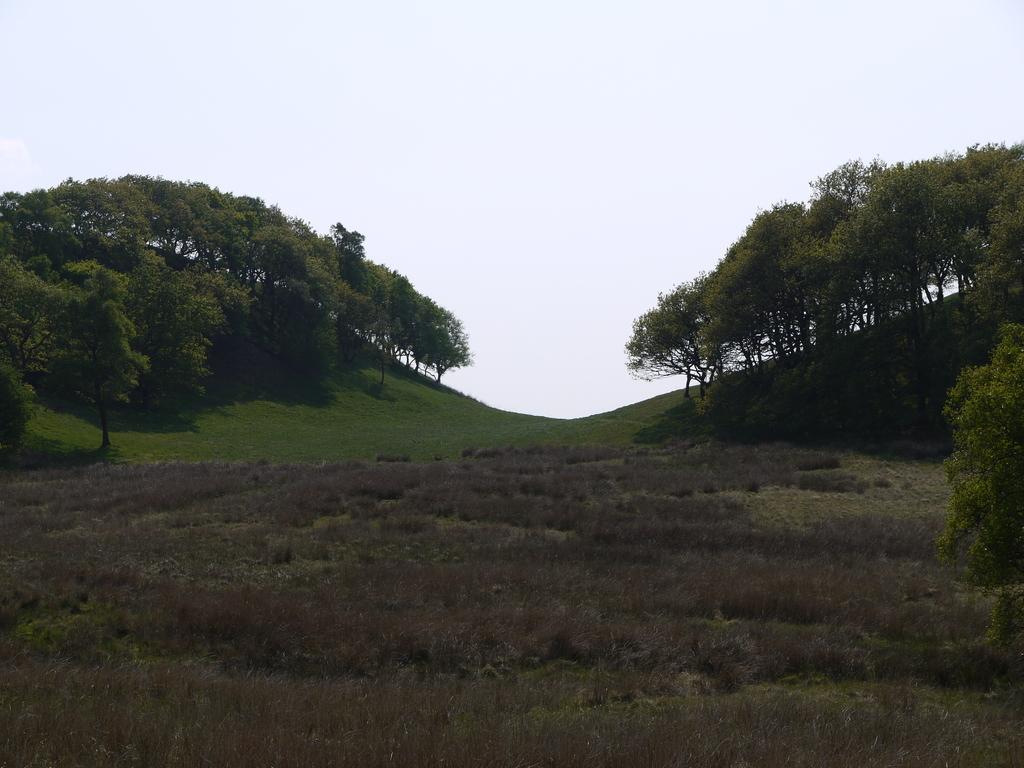Can you describe this image briefly? In this picture we can see there are trees, grass and the sky. 